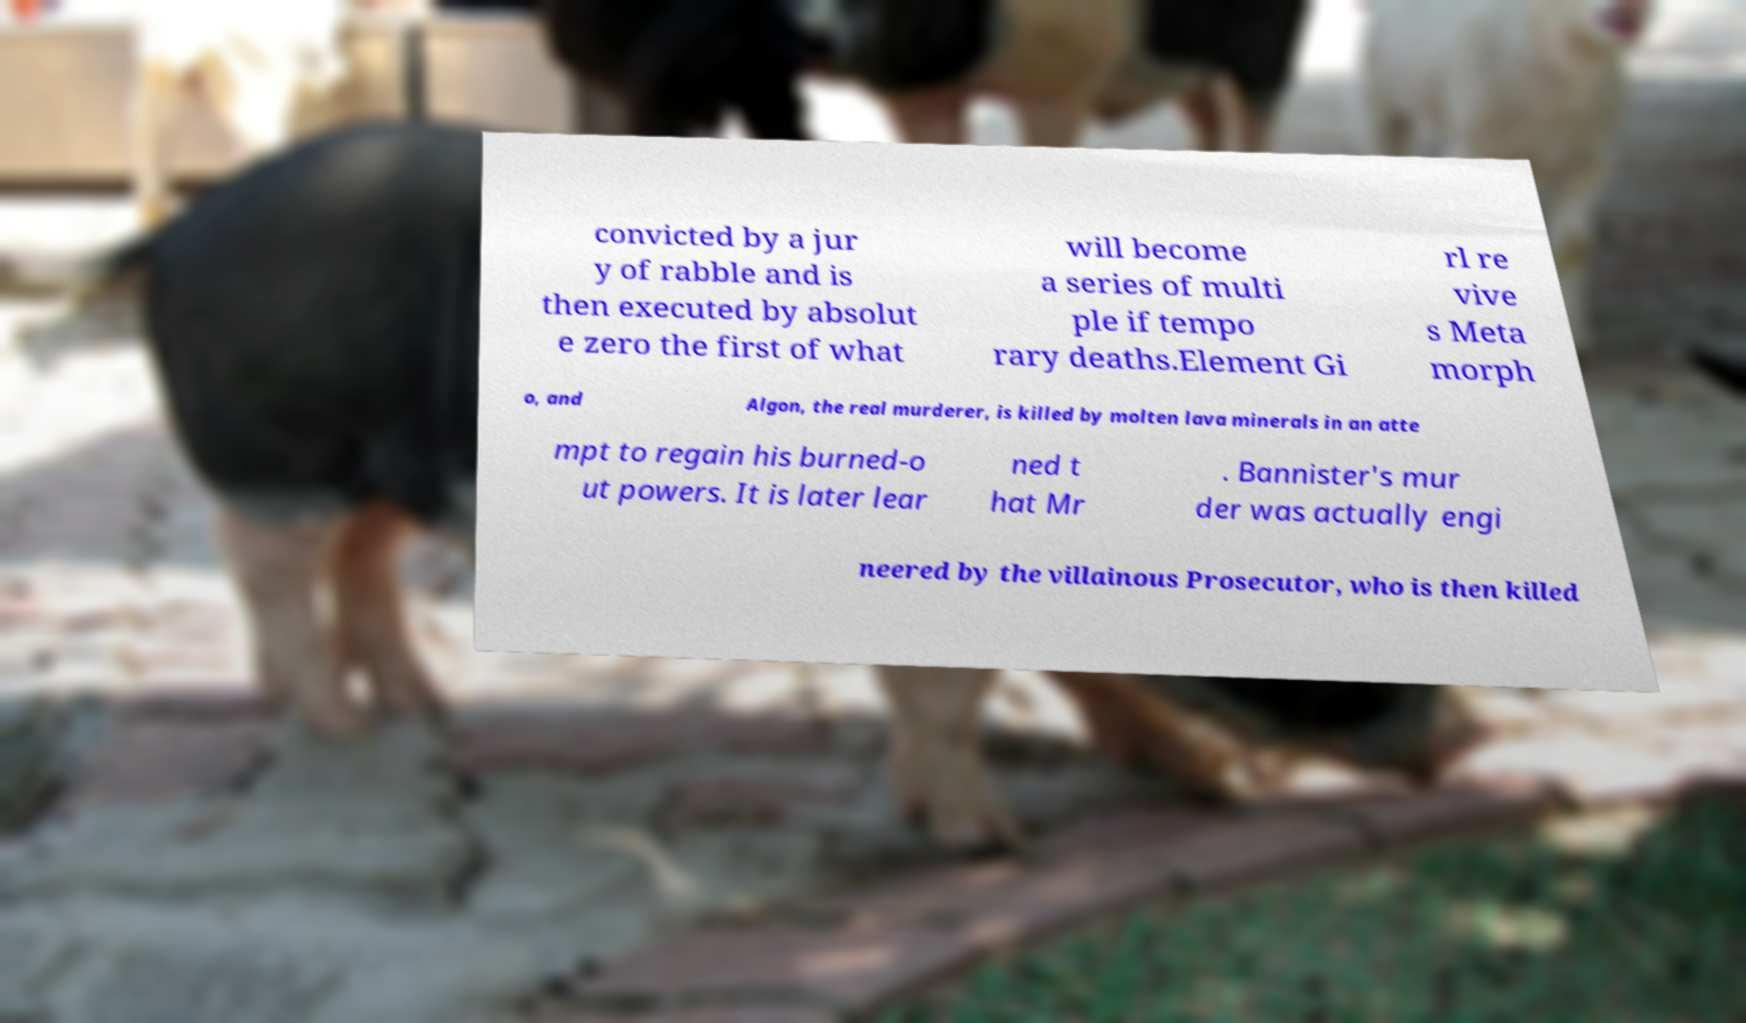Can you accurately transcribe the text from the provided image for me? convicted by a jur y of rabble and is then executed by absolut e zero the first of what will become a series of multi ple if tempo rary deaths.Element Gi rl re vive s Meta morph o, and Algon, the real murderer, is killed by molten lava minerals in an atte mpt to regain his burned-o ut powers. It is later lear ned t hat Mr . Bannister's mur der was actually engi neered by the villainous Prosecutor, who is then killed 